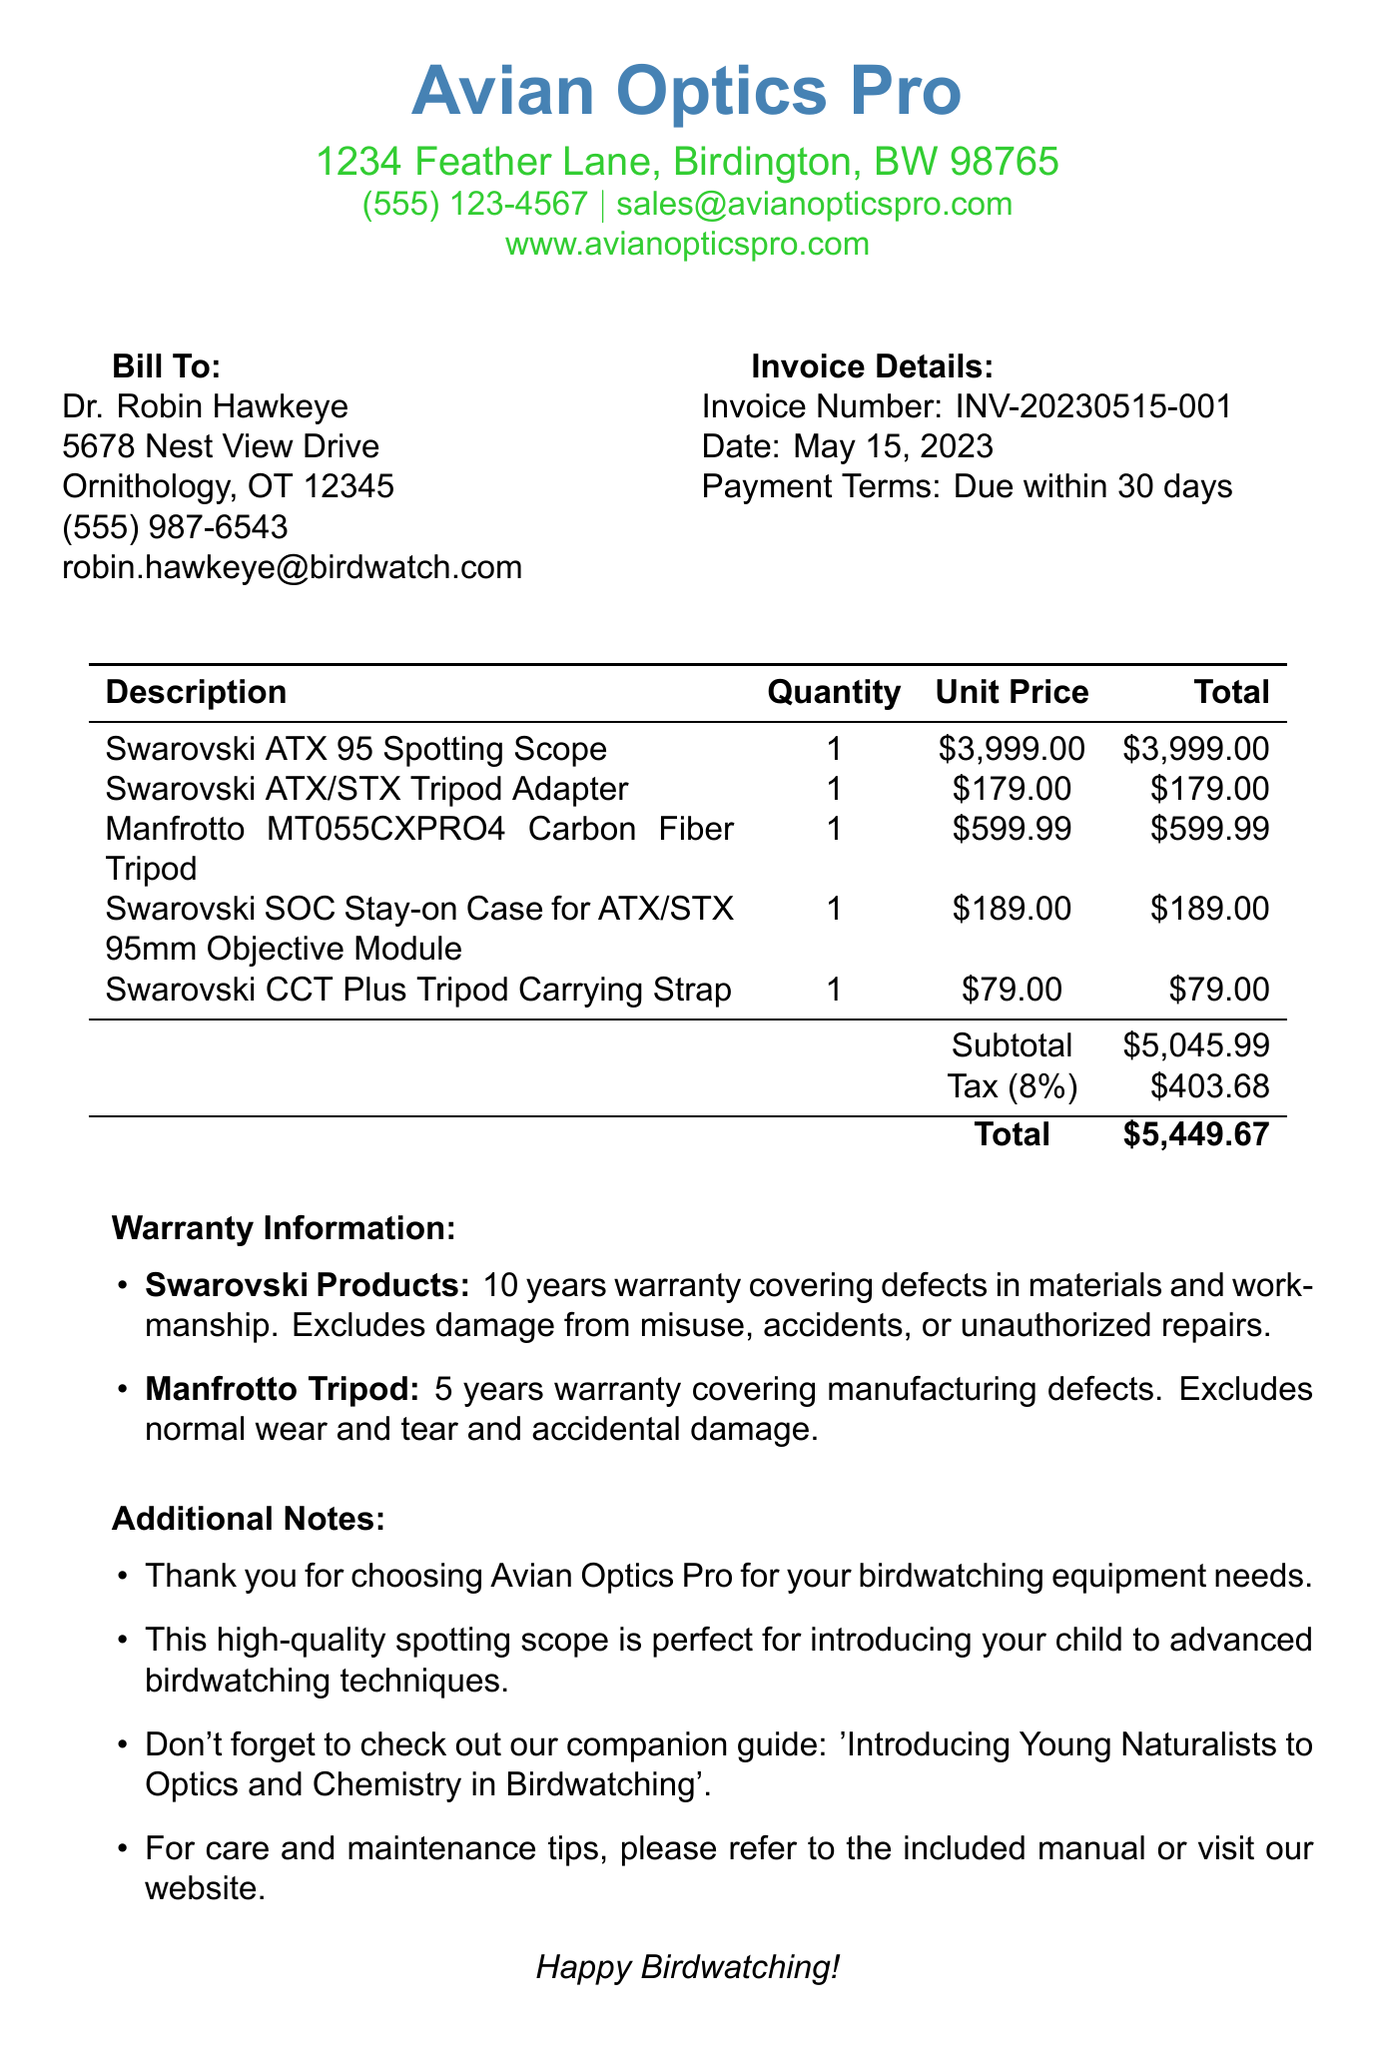What is the name of the company? The company's name is located at the top of the invoice, which identifies who issued it.
Answer: Avian Optics Pro What is the invoice number? The invoice number is a unique identifier found in the invoice details section.
Answer: INV-20230515-001 What is the total amount due? The total amount due is calculated at the bottom of the invoice after subtotal and tax.
Answer: $5,449.67 How long is the warranty for Swarovski products? The warranty duration for Swarovski products is specified in the warranty information.
Answer: 10 years What is the quantity of the Manfrotto tripod purchased? The quantity is listed in the itemized section for each product.
Answer: 1 What percentage is the tax rate? The tax rate is provided in the invoice, which applies to the subtotal amount.
Answer: 8% What type of warranty covers the Manfrotto tripod? The warranty coverage is detailed in the warranty information section for the specific item.
Answer: Manufacturing defects What is the date of the invoice? The date of the invoice is mentioned in the invoice details section.
Answer: May 15, 2023 What is included in the additional notes? The additional notes include a thank you message and recommendations, notable for customer engagement.
Answer: Thank you for choosing Avian Optics Pro for your birdwatching equipment needs 